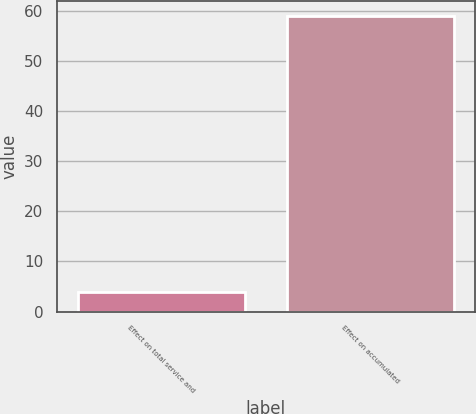Convert chart. <chart><loc_0><loc_0><loc_500><loc_500><bar_chart><fcel>Effect on total service and<fcel>Effect on accumulated<nl><fcel>4<fcel>59<nl></chart> 